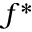Convert formula to latex. <formula><loc_0><loc_0><loc_500><loc_500>f ^ { * }</formula> 